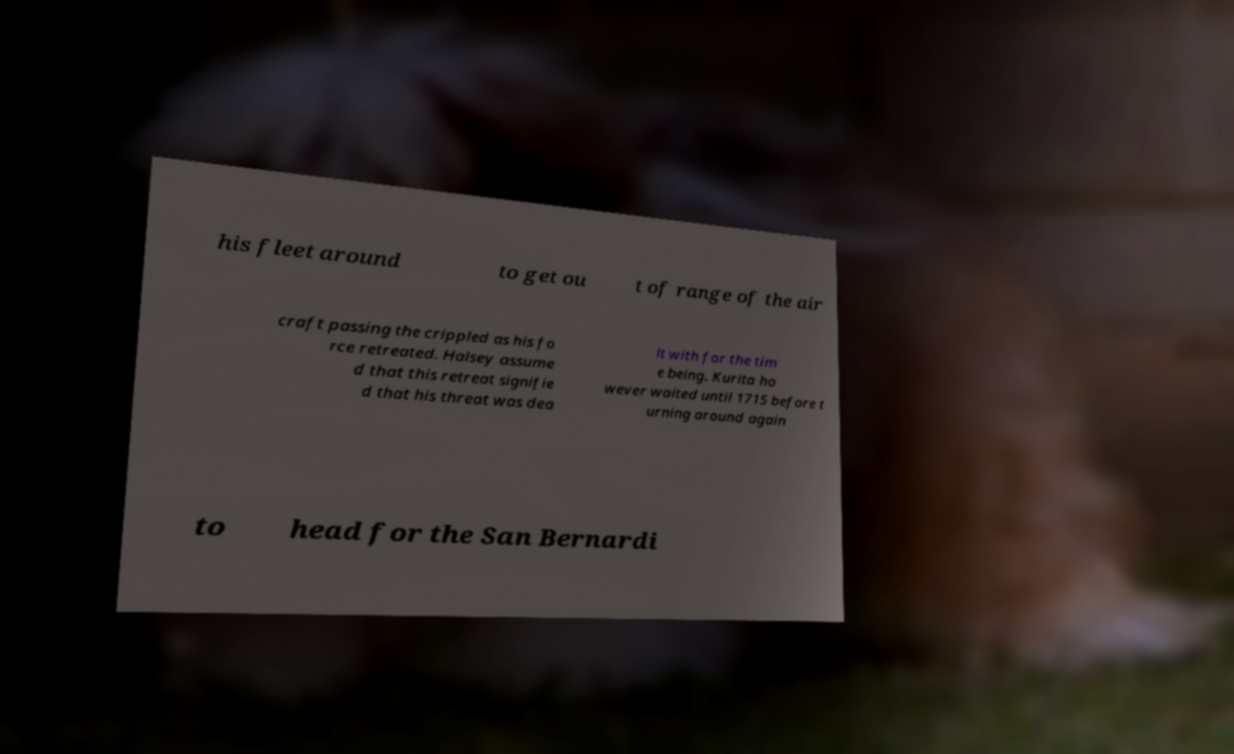Can you read and provide the text displayed in the image?This photo seems to have some interesting text. Can you extract and type it out for me? his fleet around to get ou t of range of the air craft passing the crippled as his fo rce retreated. Halsey assume d that this retreat signifie d that his threat was dea lt with for the tim e being. Kurita ho wever waited until 1715 before t urning around again to head for the San Bernardi 